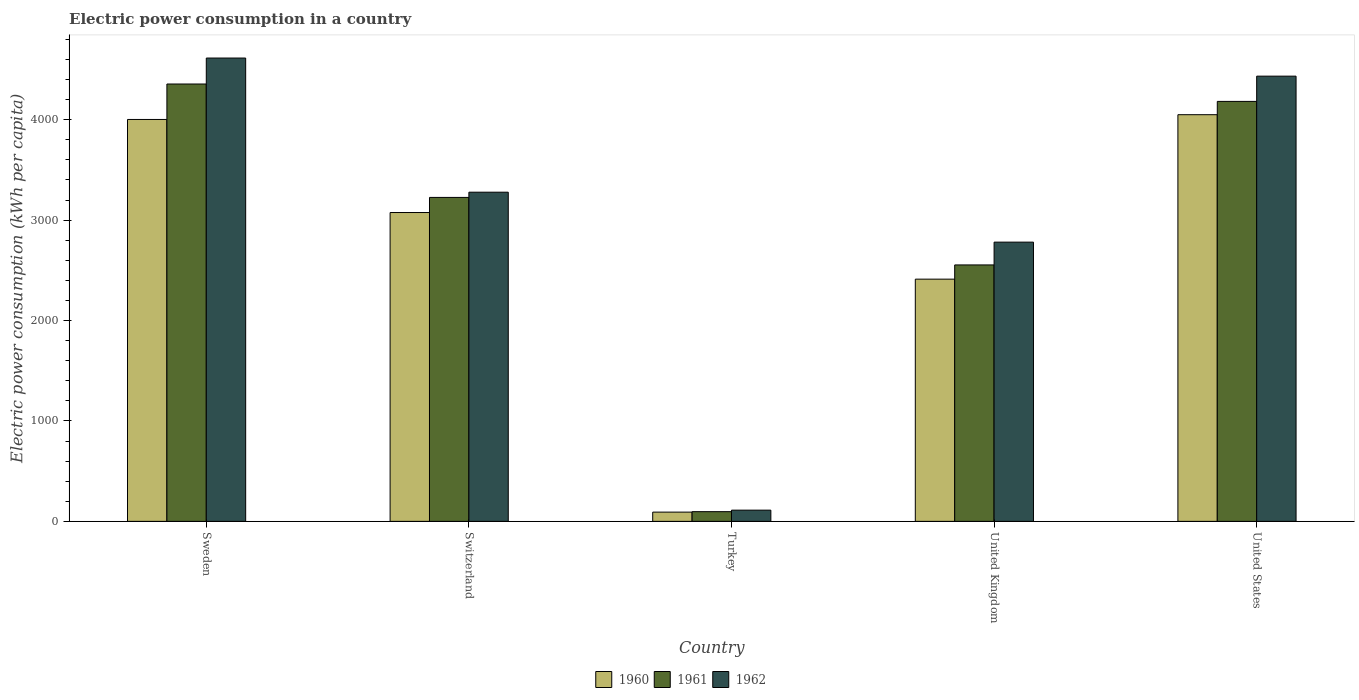How many groups of bars are there?
Make the answer very short. 5. Are the number of bars on each tick of the X-axis equal?
Give a very brief answer. Yes. How many bars are there on the 2nd tick from the left?
Ensure brevity in your answer.  3. In how many cases, is the number of bars for a given country not equal to the number of legend labels?
Offer a terse response. 0. What is the electric power consumption in in 1962 in United Kingdom?
Your answer should be compact. 2780.66. Across all countries, what is the maximum electric power consumption in in 1962?
Provide a succinct answer. 4613.98. Across all countries, what is the minimum electric power consumption in in 1960?
Your answer should be compact. 92.04. In which country was the electric power consumption in in 1960 maximum?
Provide a succinct answer. United States. In which country was the electric power consumption in in 1962 minimum?
Your answer should be very brief. Turkey. What is the total electric power consumption in in 1962 in the graph?
Provide a short and direct response. 1.52e+04. What is the difference between the electric power consumption in in 1961 in Switzerland and that in United States?
Provide a short and direct response. -956.18. What is the difference between the electric power consumption in in 1962 in Switzerland and the electric power consumption in in 1961 in Sweden?
Give a very brief answer. -1077.45. What is the average electric power consumption in in 1960 per country?
Your answer should be compact. 2726.37. What is the difference between the electric power consumption in of/in 1962 and electric power consumption in of/in 1960 in United States?
Give a very brief answer. 383.82. In how many countries, is the electric power consumption in in 1961 greater than 600 kWh per capita?
Offer a very short reply. 4. What is the ratio of the electric power consumption in in 1961 in United Kingdom to that in United States?
Provide a succinct answer. 0.61. Is the electric power consumption in in 1962 in United Kingdom less than that in United States?
Make the answer very short. Yes. What is the difference between the highest and the second highest electric power consumption in in 1960?
Give a very brief answer. 47.47. What is the difference between the highest and the lowest electric power consumption in in 1960?
Offer a terse response. 3957.75. What does the 3rd bar from the left in Turkey represents?
Your answer should be very brief. 1962. What does the 3rd bar from the right in Sweden represents?
Your response must be concise. 1960. Is it the case that in every country, the sum of the electric power consumption in in 1960 and electric power consumption in in 1962 is greater than the electric power consumption in in 1961?
Keep it short and to the point. Yes. Are all the bars in the graph horizontal?
Provide a short and direct response. No. What is the difference between two consecutive major ticks on the Y-axis?
Make the answer very short. 1000. Are the values on the major ticks of Y-axis written in scientific E-notation?
Give a very brief answer. No. Does the graph contain any zero values?
Your answer should be very brief. No. Does the graph contain grids?
Your response must be concise. No. Where does the legend appear in the graph?
Your response must be concise. Bottom center. How are the legend labels stacked?
Give a very brief answer. Horizontal. What is the title of the graph?
Offer a terse response. Electric power consumption in a country. Does "1981" appear as one of the legend labels in the graph?
Provide a succinct answer. No. What is the label or title of the Y-axis?
Ensure brevity in your answer.  Electric power consumption (kWh per capita). What is the Electric power consumption (kWh per capita) in 1960 in Sweden?
Your answer should be compact. 4002.32. What is the Electric power consumption (kWh per capita) in 1961 in Sweden?
Your answer should be compact. 4355.45. What is the Electric power consumption (kWh per capita) of 1962 in Sweden?
Keep it short and to the point. 4613.98. What is the Electric power consumption (kWh per capita) in 1960 in Switzerland?
Provide a succinct answer. 3075.55. What is the Electric power consumption (kWh per capita) of 1961 in Switzerland?
Provide a succinct answer. 3225.99. What is the Electric power consumption (kWh per capita) of 1962 in Switzerland?
Offer a terse response. 3278.01. What is the Electric power consumption (kWh per capita) in 1960 in Turkey?
Provide a short and direct response. 92.04. What is the Electric power consumption (kWh per capita) of 1961 in Turkey?
Offer a terse response. 96.64. What is the Electric power consumption (kWh per capita) of 1962 in Turkey?
Offer a very short reply. 111.76. What is the Electric power consumption (kWh per capita) in 1960 in United Kingdom?
Make the answer very short. 2412.14. What is the Electric power consumption (kWh per capita) of 1961 in United Kingdom?
Your answer should be very brief. 2553.69. What is the Electric power consumption (kWh per capita) of 1962 in United Kingdom?
Make the answer very short. 2780.66. What is the Electric power consumption (kWh per capita) of 1960 in United States?
Offer a terse response. 4049.79. What is the Electric power consumption (kWh per capita) in 1961 in United States?
Provide a succinct answer. 4182.18. What is the Electric power consumption (kWh per capita) in 1962 in United States?
Offer a terse response. 4433.61. Across all countries, what is the maximum Electric power consumption (kWh per capita) in 1960?
Your answer should be compact. 4049.79. Across all countries, what is the maximum Electric power consumption (kWh per capita) of 1961?
Offer a very short reply. 4355.45. Across all countries, what is the maximum Electric power consumption (kWh per capita) of 1962?
Give a very brief answer. 4613.98. Across all countries, what is the minimum Electric power consumption (kWh per capita) in 1960?
Offer a terse response. 92.04. Across all countries, what is the minimum Electric power consumption (kWh per capita) of 1961?
Give a very brief answer. 96.64. Across all countries, what is the minimum Electric power consumption (kWh per capita) in 1962?
Offer a terse response. 111.76. What is the total Electric power consumption (kWh per capita) of 1960 in the graph?
Ensure brevity in your answer.  1.36e+04. What is the total Electric power consumption (kWh per capita) of 1961 in the graph?
Your answer should be compact. 1.44e+04. What is the total Electric power consumption (kWh per capita) of 1962 in the graph?
Your response must be concise. 1.52e+04. What is the difference between the Electric power consumption (kWh per capita) of 1960 in Sweden and that in Switzerland?
Make the answer very short. 926.77. What is the difference between the Electric power consumption (kWh per capita) of 1961 in Sweden and that in Switzerland?
Your answer should be very brief. 1129.46. What is the difference between the Electric power consumption (kWh per capita) in 1962 in Sweden and that in Switzerland?
Your answer should be very brief. 1335.97. What is the difference between the Electric power consumption (kWh per capita) in 1960 in Sweden and that in Turkey?
Give a very brief answer. 3910.28. What is the difference between the Electric power consumption (kWh per capita) of 1961 in Sweden and that in Turkey?
Keep it short and to the point. 4258.82. What is the difference between the Electric power consumption (kWh per capita) in 1962 in Sweden and that in Turkey?
Give a very brief answer. 4502.22. What is the difference between the Electric power consumption (kWh per capita) of 1960 in Sweden and that in United Kingdom?
Offer a terse response. 1590.18. What is the difference between the Electric power consumption (kWh per capita) of 1961 in Sweden and that in United Kingdom?
Offer a terse response. 1801.76. What is the difference between the Electric power consumption (kWh per capita) of 1962 in Sweden and that in United Kingdom?
Ensure brevity in your answer.  1833.32. What is the difference between the Electric power consumption (kWh per capita) of 1960 in Sweden and that in United States?
Your response must be concise. -47.47. What is the difference between the Electric power consumption (kWh per capita) in 1961 in Sweden and that in United States?
Provide a succinct answer. 173.28. What is the difference between the Electric power consumption (kWh per capita) of 1962 in Sweden and that in United States?
Make the answer very short. 180.37. What is the difference between the Electric power consumption (kWh per capita) in 1960 in Switzerland and that in Turkey?
Make the answer very short. 2983.51. What is the difference between the Electric power consumption (kWh per capita) in 1961 in Switzerland and that in Turkey?
Offer a very short reply. 3129.36. What is the difference between the Electric power consumption (kWh per capita) of 1962 in Switzerland and that in Turkey?
Ensure brevity in your answer.  3166.25. What is the difference between the Electric power consumption (kWh per capita) of 1960 in Switzerland and that in United Kingdom?
Offer a very short reply. 663.41. What is the difference between the Electric power consumption (kWh per capita) of 1961 in Switzerland and that in United Kingdom?
Offer a very short reply. 672.3. What is the difference between the Electric power consumption (kWh per capita) of 1962 in Switzerland and that in United Kingdom?
Keep it short and to the point. 497.35. What is the difference between the Electric power consumption (kWh per capita) in 1960 in Switzerland and that in United States?
Offer a very short reply. -974.24. What is the difference between the Electric power consumption (kWh per capita) of 1961 in Switzerland and that in United States?
Ensure brevity in your answer.  -956.18. What is the difference between the Electric power consumption (kWh per capita) of 1962 in Switzerland and that in United States?
Provide a succinct answer. -1155.6. What is the difference between the Electric power consumption (kWh per capita) of 1960 in Turkey and that in United Kingdom?
Your answer should be very brief. -2320.1. What is the difference between the Electric power consumption (kWh per capita) in 1961 in Turkey and that in United Kingdom?
Your answer should be compact. -2457.06. What is the difference between the Electric power consumption (kWh per capita) of 1962 in Turkey and that in United Kingdom?
Your answer should be very brief. -2668.9. What is the difference between the Electric power consumption (kWh per capita) of 1960 in Turkey and that in United States?
Your answer should be very brief. -3957.75. What is the difference between the Electric power consumption (kWh per capita) of 1961 in Turkey and that in United States?
Provide a short and direct response. -4085.54. What is the difference between the Electric power consumption (kWh per capita) of 1962 in Turkey and that in United States?
Offer a very short reply. -4321.85. What is the difference between the Electric power consumption (kWh per capita) in 1960 in United Kingdom and that in United States?
Offer a terse response. -1637.65. What is the difference between the Electric power consumption (kWh per capita) of 1961 in United Kingdom and that in United States?
Provide a succinct answer. -1628.48. What is the difference between the Electric power consumption (kWh per capita) in 1962 in United Kingdom and that in United States?
Your answer should be very brief. -1652.95. What is the difference between the Electric power consumption (kWh per capita) in 1960 in Sweden and the Electric power consumption (kWh per capita) in 1961 in Switzerland?
Provide a succinct answer. 776.33. What is the difference between the Electric power consumption (kWh per capita) in 1960 in Sweden and the Electric power consumption (kWh per capita) in 1962 in Switzerland?
Offer a terse response. 724.32. What is the difference between the Electric power consumption (kWh per capita) of 1961 in Sweden and the Electric power consumption (kWh per capita) of 1962 in Switzerland?
Your answer should be compact. 1077.45. What is the difference between the Electric power consumption (kWh per capita) in 1960 in Sweden and the Electric power consumption (kWh per capita) in 1961 in Turkey?
Ensure brevity in your answer.  3905.68. What is the difference between the Electric power consumption (kWh per capita) in 1960 in Sweden and the Electric power consumption (kWh per capita) in 1962 in Turkey?
Your response must be concise. 3890.56. What is the difference between the Electric power consumption (kWh per capita) of 1961 in Sweden and the Electric power consumption (kWh per capita) of 1962 in Turkey?
Keep it short and to the point. 4243.69. What is the difference between the Electric power consumption (kWh per capita) of 1960 in Sweden and the Electric power consumption (kWh per capita) of 1961 in United Kingdom?
Offer a very short reply. 1448.63. What is the difference between the Electric power consumption (kWh per capita) in 1960 in Sweden and the Electric power consumption (kWh per capita) in 1962 in United Kingdom?
Keep it short and to the point. 1221.66. What is the difference between the Electric power consumption (kWh per capita) of 1961 in Sweden and the Electric power consumption (kWh per capita) of 1962 in United Kingdom?
Your answer should be very brief. 1574.8. What is the difference between the Electric power consumption (kWh per capita) of 1960 in Sweden and the Electric power consumption (kWh per capita) of 1961 in United States?
Keep it short and to the point. -179.85. What is the difference between the Electric power consumption (kWh per capita) of 1960 in Sweden and the Electric power consumption (kWh per capita) of 1962 in United States?
Your answer should be compact. -431.28. What is the difference between the Electric power consumption (kWh per capita) of 1961 in Sweden and the Electric power consumption (kWh per capita) of 1962 in United States?
Give a very brief answer. -78.15. What is the difference between the Electric power consumption (kWh per capita) of 1960 in Switzerland and the Electric power consumption (kWh per capita) of 1961 in Turkey?
Keep it short and to the point. 2978.91. What is the difference between the Electric power consumption (kWh per capita) in 1960 in Switzerland and the Electric power consumption (kWh per capita) in 1962 in Turkey?
Offer a terse response. 2963.79. What is the difference between the Electric power consumption (kWh per capita) in 1961 in Switzerland and the Electric power consumption (kWh per capita) in 1962 in Turkey?
Your response must be concise. 3114.23. What is the difference between the Electric power consumption (kWh per capita) of 1960 in Switzerland and the Electric power consumption (kWh per capita) of 1961 in United Kingdom?
Give a very brief answer. 521.86. What is the difference between the Electric power consumption (kWh per capita) in 1960 in Switzerland and the Electric power consumption (kWh per capita) in 1962 in United Kingdom?
Your answer should be very brief. 294.89. What is the difference between the Electric power consumption (kWh per capita) of 1961 in Switzerland and the Electric power consumption (kWh per capita) of 1962 in United Kingdom?
Your answer should be very brief. 445.34. What is the difference between the Electric power consumption (kWh per capita) in 1960 in Switzerland and the Electric power consumption (kWh per capita) in 1961 in United States?
Your answer should be compact. -1106.63. What is the difference between the Electric power consumption (kWh per capita) in 1960 in Switzerland and the Electric power consumption (kWh per capita) in 1962 in United States?
Give a very brief answer. -1358.06. What is the difference between the Electric power consumption (kWh per capita) in 1961 in Switzerland and the Electric power consumption (kWh per capita) in 1962 in United States?
Make the answer very short. -1207.61. What is the difference between the Electric power consumption (kWh per capita) in 1960 in Turkey and the Electric power consumption (kWh per capita) in 1961 in United Kingdom?
Offer a terse response. -2461.65. What is the difference between the Electric power consumption (kWh per capita) of 1960 in Turkey and the Electric power consumption (kWh per capita) of 1962 in United Kingdom?
Provide a short and direct response. -2688.62. What is the difference between the Electric power consumption (kWh per capita) of 1961 in Turkey and the Electric power consumption (kWh per capita) of 1962 in United Kingdom?
Keep it short and to the point. -2684.02. What is the difference between the Electric power consumption (kWh per capita) in 1960 in Turkey and the Electric power consumption (kWh per capita) in 1961 in United States?
Your answer should be compact. -4090.14. What is the difference between the Electric power consumption (kWh per capita) in 1960 in Turkey and the Electric power consumption (kWh per capita) in 1962 in United States?
Provide a succinct answer. -4341.57. What is the difference between the Electric power consumption (kWh per capita) in 1961 in Turkey and the Electric power consumption (kWh per capita) in 1962 in United States?
Ensure brevity in your answer.  -4336.97. What is the difference between the Electric power consumption (kWh per capita) in 1960 in United Kingdom and the Electric power consumption (kWh per capita) in 1961 in United States?
Provide a succinct answer. -1770.04. What is the difference between the Electric power consumption (kWh per capita) in 1960 in United Kingdom and the Electric power consumption (kWh per capita) in 1962 in United States?
Provide a succinct answer. -2021.47. What is the difference between the Electric power consumption (kWh per capita) of 1961 in United Kingdom and the Electric power consumption (kWh per capita) of 1962 in United States?
Make the answer very short. -1879.91. What is the average Electric power consumption (kWh per capita) in 1960 per country?
Give a very brief answer. 2726.37. What is the average Electric power consumption (kWh per capita) in 1961 per country?
Give a very brief answer. 2882.79. What is the average Electric power consumption (kWh per capita) of 1962 per country?
Keep it short and to the point. 3043.6. What is the difference between the Electric power consumption (kWh per capita) in 1960 and Electric power consumption (kWh per capita) in 1961 in Sweden?
Provide a short and direct response. -353.13. What is the difference between the Electric power consumption (kWh per capita) of 1960 and Electric power consumption (kWh per capita) of 1962 in Sweden?
Keep it short and to the point. -611.66. What is the difference between the Electric power consumption (kWh per capita) in 1961 and Electric power consumption (kWh per capita) in 1962 in Sweden?
Provide a short and direct response. -258.52. What is the difference between the Electric power consumption (kWh per capita) in 1960 and Electric power consumption (kWh per capita) in 1961 in Switzerland?
Keep it short and to the point. -150.44. What is the difference between the Electric power consumption (kWh per capita) in 1960 and Electric power consumption (kWh per capita) in 1962 in Switzerland?
Your response must be concise. -202.46. What is the difference between the Electric power consumption (kWh per capita) in 1961 and Electric power consumption (kWh per capita) in 1962 in Switzerland?
Provide a short and direct response. -52.01. What is the difference between the Electric power consumption (kWh per capita) of 1960 and Electric power consumption (kWh per capita) of 1961 in Turkey?
Provide a short and direct response. -4.6. What is the difference between the Electric power consumption (kWh per capita) in 1960 and Electric power consumption (kWh per capita) in 1962 in Turkey?
Keep it short and to the point. -19.72. What is the difference between the Electric power consumption (kWh per capita) of 1961 and Electric power consumption (kWh per capita) of 1962 in Turkey?
Provide a succinct answer. -15.12. What is the difference between the Electric power consumption (kWh per capita) of 1960 and Electric power consumption (kWh per capita) of 1961 in United Kingdom?
Provide a short and direct response. -141.56. What is the difference between the Electric power consumption (kWh per capita) of 1960 and Electric power consumption (kWh per capita) of 1962 in United Kingdom?
Keep it short and to the point. -368.52. What is the difference between the Electric power consumption (kWh per capita) in 1961 and Electric power consumption (kWh per capita) in 1962 in United Kingdom?
Provide a succinct answer. -226.96. What is the difference between the Electric power consumption (kWh per capita) in 1960 and Electric power consumption (kWh per capita) in 1961 in United States?
Provide a short and direct response. -132.39. What is the difference between the Electric power consumption (kWh per capita) in 1960 and Electric power consumption (kWh per capita) in 1962 in United States?
Make the answer very short. -383.82. What is the difference between the Electric power consumption (kWh per capita) of 1961 and Electric power consumption (kWh per capita) of 1962 in United States?
Ensure brevity in your answer.  -251.43. What is the ratio of the Electric power consumption (kWh per capita) in 1960 in Sweden to that in Switzerland?
Offer a very short reply. 1.3. What is the ratio of the Electric power consumption (kWh per capita) in 1961 in Sweden to that in Switzerland?
Your answer should be compact. 1.35. What is the ratio of the Electric power consumption (kWh per capita) in 1962 in Sweden to that in Switzerland?
Your response must be concise. 1.41. What is the ratio of the Electric power consumption (kWh per capita) of 1960 in Sweden to that in Turkey?
Keep it short and to the point. 43.48. What is the ratio of the Electric power consumption (kWh per capita) in 1961 in Sweden to that in Turkey?
Your response must be concise. 45.07. What is the ratio of the Electric power consumption (kWh per capita) in 1962 in Sweden to that in Turkey?
Provide a succinct answer. 41.28. What is the ratio of the Electric power consumption (kWh per capita) of 1960 in Sweden to that in United Kingdom?
Keep it short and to the point. 1.66. What is the ratio of the Electric power consumption (kWh per capita) of 1961 in Sweden to that in United Kingdom?
Provide a short and direct response. 1.71. What is the ratio of the Electric power consumption (kWh per capita) of 1962 in Sweden to that in United Kingdom?
Your answer should be compact. 1.66. What is the ratio of the Electric power consumption (kWh per capita) in 1960 in Sweden to that in United States?
Provide a succinct answer. 0.99. What is the ratio of the Electric power consumption (kWh per capita) in 1961 in Sweden to that in United States?
Your response must be concise. 1.04. What is the ratio of the Electric power consumption (kWh per capita) of 1962 in Sweden to that in United States?
Your answer should be compact. 1.04. What is the ratio of the Electric power consumption (kWh per capita) of 1960 in Switzerland to that in Turkey?
Provide a short and direct response. 33.42. What is the ratio of the Electric power consumption (kWh per capita) in 1961 in Switzerland to that in Turkey?
Provide a short and direct response. 33.38. What is the ratio of the Electric power consumption (kWh per capita) of 1962 in Switzerland to that in Turkey?
Keep it short and to the point. 29.33. What is the ratio of the Electric power consumption (kWh per capita) in 1960 in Switzerland to that in United Kingdom?
Your answer should be very brief. 1.27. What is the ratio of the Electric power consumption (kWh per capita) in 1961 in Switzerland to that in United Kingdom?
Make the answer very short. 1.26. What is the ratio of the Electric power consumption (kWh per capita) in 1962 in Switzerland to that in United Kingdom?
Provide a short and direct response. 1.18. What is the ratio of the Electric power consumption (kWh per capita) in 1960 in Switzerland to that in United States?
Your answer should be compact. 0.76. What is the ratio of the Electric power consumption (kWh per capita) of 1961 in Switzerland to that in United States?
Provide a short and direct response. 0.77. What is the ratio of the Electric power consumption (kWh per capita) of 1962 in Switzerland to that in United States?
Provide a short and direct response. 0.74. What is the ratio of the Electric power consumption (kWh per capita) in 1960 in Turkey to that in United Kingdom?
Offer a terse response. 0.04. What is the ratio of the Electric power consumption (kWh per capita) of 1961 in Turkey to that in United Kingdom?
Make the answer very short. 0.04. What is the ratio of the Electric power consumption (kWh per capita) in 1962 in Turkey to that in United Kingdom?
Your response must be concise. 0.04. What is the ratio of the Electric power consumption (kWh per capita) in 1960 in Turkey to that in United States?
Make the answer very short. 0.02. What is the ratio of the Electric power consumption (kWh per capita) in 1961 in Turkey to that in United States?
Your answer should be compact. 0.02. What is the ratio of the Electric power consumption (kWh per capita) in 1962 in Turkey to that in United States?
Keep it short and to the point. 0.03. What is the ratio of the Electric power consumption (kWh per capita) in 1960 in United Kingdom to that in United States?
Keep it short and to the point. 0.6. What is the ratio of the Electric power consumption (kWh per capita) in 1961 in United Kingdom to that in United States?
Keep it short and to the point. 0.61. What is the ratio of the Electric power consumption (kWh per capita) of 1962 in United Kingdom to that in United States?
Ensure brevity in your answer.  0.63. What is the difference between the highest and the second highest Electric power consumption (kWh per capita) in 1960?
Offer a very short reply. 47.47. What is the difference between the highest and the second highest Electric power consumption (kWh per capita) of 1961?
Your response must be concise. 173.28. What is the difference between the highest and the second highest Electric power consumption (kWh per capita) in 1962?
Your response must be concise. 180.37. What is the difference between the highest and the lowest Electric power consumption (kWh per capita) in 1960?
Provide a short and direct response. 3957.75. What is the difference between the highest and the lowest Electric power consumption (kWh per capita) in 1961?
Ensure brevity in your answer.  4258.82. What is the difference between the highest and the lowest Electric power consumption (kWh per capita) in 1962?
Your response must be concise. 4502.22. 